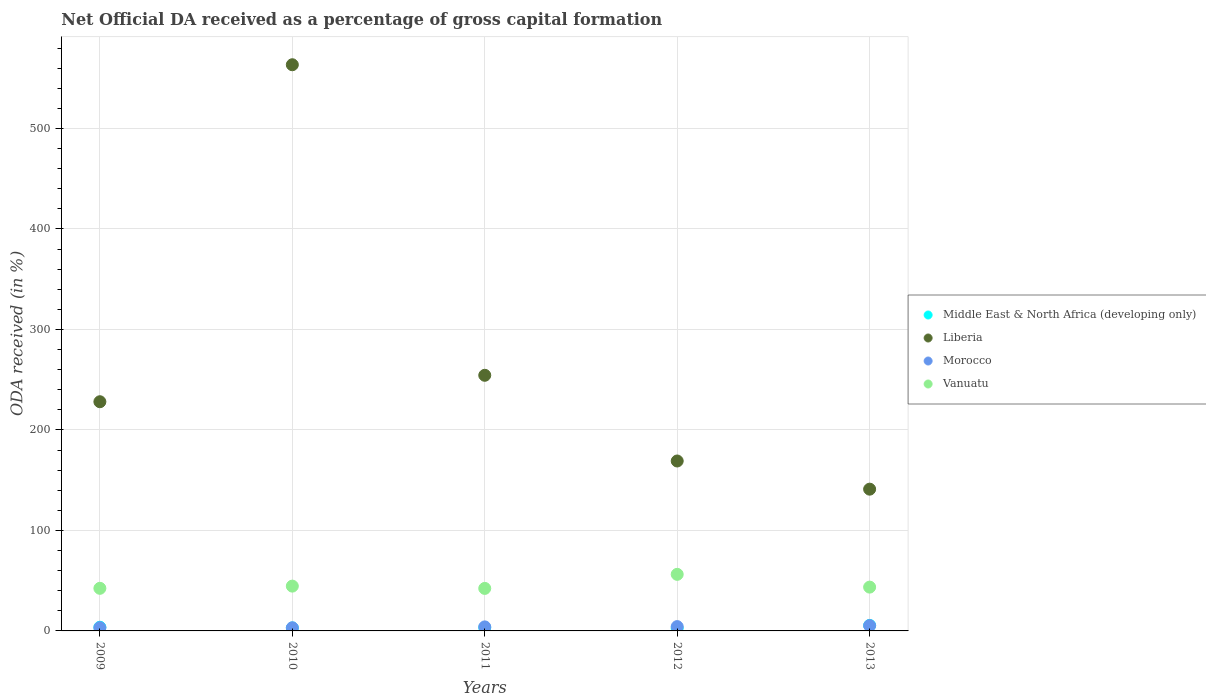What is the net ODA received in Liberia in 2011?
Offer a very short reply. 254.4. Across all years, what is the maximum net ODA received in Middle East & North Africa (developing only)?
Your response must be concise. 5.49. Across all years, what is the minimum net ODA received in Vanuatu?
Provide a short and direct response. 42.31. In which year was the net ODA received in Morocco maximum?
Offer a very short reply. 2013. In which year was the net ODA received in Morocco minimum?
Offer a very short reply. 2010. What is the total net ODA received in Vanuatu in the graph?
Your response must be concise. 229.19. What is the difference between the net ODA received in Morocco in 2010 and that in 2013?
Give a very brief answer. -2.15. What is the difference between the net ODA received in Liberia in 2011 and the net ODA received in Middle East & North Africa (developing only) in 2012?
Make the answer very short. 251.66. What is the average net ODA received in Liberia per year?
Offer a terse response. 271.22. In the year 2010, what is the difference between the net ODA received in Vanuatu and net ODA received in Morocco?
Your response must be concise. 41.47. What is the ratio of the net ODA received in Middle East & North Africa (developing only) in 2010 to that in 2013?
Make the answer very short. 0.54. Is the net ODA received in Middle East & North Africa (developing only) in 2010 less than that in 2012?
Provide a short and direct response. No. What is the difference between the highest and the second highest net ODA received in Middle East & North Africa (developing only)?
Your response must be concise. 1.82. What is the difference between the highest and the lowest net ODA received in Morocco?
Give a very brief answer. 2.15. Does the net ODA received in Liberia monotonically increase over the years?
Make the answer very short. No. How many years are there in the graph?
Make the answer very short. 5. Are the values on the major ticks of Y-axis written in scientific E-notation?
Provide a succinct answer. No. Does the graph contain grids?
Keep it short and to the point. Yes. Where does the legend appear in the graph?
Keep it short and to the point. Center right. What is the title of the graph?
Keep it short and to the point. Net Official DA received as a percentage of gross capital formation. Does "East Asia (all income levels)" appear as one of the legend labels in the graph?
Make the answer very short. No. What is the label or title of the X-axis?
Give a very brief answer. Years. What is the label or title of the Y-axis?
Keep it short and to the point. ODA received (in %). What is the ODA received (in %) in Middle East & North Africa (developing only) in 2009?
Keep it short and to the point. 3.67. What is the ODA received (in %) of Liberia in 2009?
Offer a very short reply. 228.08. What is the ODA received (in %) in Morocco in 2009?
Your answer should be compact. 3.22. What is the ODA received (in %) of Vanuatu in 2009?
Make the answer very short. 42.4. What is the ODA received (in %) of Middle East & North Africa (developing only) in 2010?
Your answer should be compact. 2.96. What is the ODA received (in %) of Liberia in 2010?
Your answer should be compact. 563.45. What is the ODA received (in %) of Morocco in 2010?
Your response must be concise. 3.12. What is the ODA received (in %) of Vanuatu in 2010?
Offer a very short reply. 44.59. What is the ODA received (in %) of Middle East & North Africa (developing only) in 2011?
Your answer should be very brief. 3.27. What is the ODA received (in %) in Liberia in 2011?
Keep it short and to the point. 254.4. What is the ODA received (in %) of Morocco in 2011?
Your answer should be very brief. 4.01. What is the ODA received (in %) of Vanuatu in 2011?
Provide a short and direct response. 42.31. What is the ODA received (in %) in Middle East & North Africa (developing only) in 2012?
Your response must be concise. 2.73. What is the ODA received (in %) in Liberia in 2012?
Make the answer very short. 169.11. What is the ODA received (in %) in Morocco in 2012?
Provide a short and direct response. 4.3. What is the ODA received (in %) of Vanuatu in 2012?
Ensure brevity in your answer.  56.3. What is the ODA received (in %) of Middle East & North Africa (developing only) in 2013?
Your response must be concise. 5.49. What is the ODA received (in %) of Liberia in 2013?
Give a very brief answer. 141.07. What is the ODA received (in %) in Morocco in 2013?
Offer a terse response. 5.28. What is the ODA received (in %) in Vanuatu in 2013?
Ensure brevity in your answer.  43.59. Across all years, what is the maximum ODA received (in %) in Middle East & North Africa (developing only)?
Provide a succinct answer. 5.49. Across all years, what is the maximum ODA received (in %) of Liberia?
Keep it short and to the point. 563.45. Across all years, what is the maximum ODA received (in %) of Morocco?
Offer a very short reply. 5.28. Across all years, what is the maximum ODA received (in %) in Vanuatu?
Offer a very short reply. 56.3. Across all years, what is the minimum ODA received (in %) in Middle East & North Africa (developing only)?
Make the answer very short. 2.73. Across all years, what is the minimum ODA received (in %) in Liberia?
Make the answer very short. 141.07. Across all years, what is the minimum ODA received (in %) in Morocco?
Provide a succinct answer. 3.12. Across all years, what is the minimum ODA received (in %) of Vanuatu?
Keep it short and to the point. 42.31. What is the total ODA received (in %) of Middle East & North Africa (developing only) in the graph?
Keep it short and to the point. 18.11. What is the total ODA received (in %) of Liberia in the graph?
Offer a terse response. 1356.11. What is the total ODA received (in %) in Morocco in the graph?
Your answer should be very brief. 19.94. What is the total ODA received (in %) in Vanuatu in the graph?
Give a very brief answer. 229.19. What is the difference between the ODA received (in %) in Middle East & North Africa (developing only) in 2009 and that in 2010?
Offer a very short reply. 0.71. What is the difference between the ODA received (in %) of Liberia in 2009 and that in 2010?
Your answer should be very brief. -335.37. What is the difference between the ODA received (in %) of Morocco in 2009 and that in 2010?
Ensure brevity in your answer.  0.09. What is the difference between the ODA received (in %) in Vanuatu in 2009 and that in 2010?
Your answer should be very brief. -2.19. What is the difference between the ODA received (in %) in Middle East & North Africa (developing only) in 2009 and that in 2011?
Provide a short and direct response. 0.4. What is the difference between the ODA received (in %) in Liberia in 2009 and that in 2011?
Your response must be concise. -26.31. What is the difference between the ODA received (in %) in Morocco in 2009 and that in 2011?
Make the answer very short. -0.8. What is the difference between the ODA received (in %) of Vanuatu in 2009 and that in 2011?
Your answer should be compact. 0.09. What is the difference between the ODA received (in %) of Middle East & North Africa (developing only) in 2009 and that in 2012?
Offer a terse response. 0.93. What is the difference between the ODA received (in %) in Liberia in 2009 and that in 2012?
Give a very brief answer. 58.97. What is the difference between the ODA received (in %) in Morocco in 2009 and that in 2012?
Make the answer very short. -1.09. What is the difference between the ODA received (in %) of Middle East & North Africa (developing only) in 2009 and that in 2013?
Provide a succinct answer. -1.82. What is the difference between the ODA received (in %) of Liberia in 2009 and that in 2013?
Ensure brevity in your answer.  87.01. What is the difference between the ODA received (in %) of Morocco in 2009 and that in 2013?
Provide a short and direct response. -2.06. What is the difference between the ODA received (in %) of Vanuatu in 2009 and that in 2013?
Provide a succinct answer. -1.19. What is the difference between the ODA received (in %) in Middle East & North Africa (developing only) in 2010 and that in 2011?
Your answer should be very brief. -0.31. What is the difference between the ODA received (in %) in Liberia in 2010 and that in 2011?
Give a very brief answer. 309.05. What is the difference between the ODA received (in %) in Morocco in 2010 and that in 2011?
Provide a short and direct response. -0.89. What is the difference between the ODA received (in %) in Vanuatu in 2010 and that in 2011?
Keep it short and to the point. 2.29. What is the difference between the ODA received (in %) in Middle East & North Africa (developing only) in 2010 and that in 2012?
Make the answer very short. 0.23. What is the difference between the ODA received (in %) in Liberia in 2010 and that in 2012?
Your response must be concise. 394.34. What is the difference between the ODA received (in %) of Morocco in 2010 and that in 2012?
Provide a succinct answer. -1.18. What is the difference between the ODA received (in %) in Vanuatu in 2010 and that in 2012?
Your answer should be very brief. -11.71. What is the difference between the ODA received (in %) of Middle East & North Africa (developing only) in 2010 and that in 2013?
Provide a short and direct response. -2.53. What is the difference between the ODA received (in %) in Liberia in 2010 and that in 2013?
Ensure brevity in your answer.  422.38. What is the difference between the ODA received (in %) in Morocco in 2010 and that in 2013?
Your answer should be compact. -2.15. What is the difference between the ODA received (in %) of Vanuatu in 2010 and that in 2013?
Provide a short and direct response. 1. What is the difference between the ODA received (in %) in Middle East & North Africa (developing only) in 2011 and that in 2012?
Provide a short and direct response. 0.53. What is the difference between the ODA received (in %) of Liberia in 2011 and that in 2012?
Ensure brevity in your answer.  85.29. What is the difference between the ODA received (in %) in Morocco in 2011 and that in 2012?
Your answer should be compact. -0.29. What is the difference between the ODA received (in %) of Vanuatu in 2011 and that in 2012?
Ensure brevity in your answer.  -13.99. What is the difference between the ODA received (in %) in Middle East & North Africa (developing only) in 2011 and that in 2013?
Provide a succinct answer. -2.22. What is the difference between the ODA received (in %) of Liberia in 2011 and that in 2013?
Your response must be concise. 113.32. What is the difference between the ODA received (in %) in Morocco in 2011 and that in 2013?
Ensure brevity in your answer.  -1.26. What is the difference between the ODA received (in %) of Vanuatu in 2011 and that in 2013?
Make the answer very short. -1.28. What is the difference between the ODA received (in %) of Middle East & North Africa (developing only) in 2012 and that in 2013?
Offer a very short reply. -2.76. What is the difference between the ODA received (in %) of Liberia in 2012 and that in 2013?
Provide a short and direct response. 28.04. What is the difference between the ODA received (in %) of Morocco in 2012 and that in 2013?
Your response must be concise. -0.98. What is the difference between the ODA received (in %) of Vanuatu in 2012 and that in 2013?
Provide a short and direct response. 12.71. What is the difference between the ODA received (in %) of Middle East & North Africa (developing only) in 2009 and the ODA received (in %) of Liberia in 2010?
Provide a short and direct response. -559.78. What is the difference between the ODA received (in %) of Middle East & North Africa (developing only) in 2009 and the ODA received (in %) of Morocco in 2010?
Your answer should be very brief. 0.54. What is the difference between the ODA received (in %) in Middle East & North Africa (developing only) in 2009 and the ODA received (in %) in Vanuatu in 2010?
Make the answer very short. -40.93. What is the difference between the ODA received (in %) of Liberia in 2009 and the ODA received (in %) of Morocco in 2010?
Ensure brevity in your answer.  224.96. What is the difference between the ODA received (in %) of Liberia in 2009 and the ODA received (in %) of Vanuatu in 2010?
Offer a terse response. 183.49. What is the difference between the ODA received (in %) of Morocco in 2009 and the ODA received (in %) of Vanuatu in 2010?
Ensure brevity in your answer.  -41.37. What is the difference between the ODA received (in %) in Middle East & North Africa (developing only) in 2009 and the ODA received (in %) in Liberia in 2011?
Offer a very short reply. -250.73. What is the difference between the ODA received (in %) in Middle East & North Africa (developing only) in 2009 and the ODA received (in %) in Morocco in 2011?
Give a very brief answer. -0.35. What is the difference between the ODA received (in %) in Middle East & North Africa (developing only) in 2009 and the ODA received (in %) in Vanuatu in 2011?
Keep it short and to the point. -38.64. What is the difference between the ODA received (in %) of Liberia in 2009 and the ODA received (in %) of Morocco in 2011?
Give a very brief answer. 224.07. What is the difference between the ODA received (in %) in Liberia in 2009 and the ODA received (in %) in Vanuatu in 2011?
Offer a very short reply. 185.78. What is the difference between the ODA received (in %) in Morocco in 2009 and the ODA received (in %) in Vanuatu in 2011?
Make the answer very short. -39.09. What is the difference between the ODA received (in %) in Middle East & North Africa (developing only) in 2009 and the ODA received (in %) in Liberia in 2012?
Give a very brief answer. -165.44. What is the difference between the ODA received (in %) in Middle East & North Africa (developing only) in 2009 and the ODA received (in %) in Morocco in 2012?
Your response must be concise. -0.64. What is the difference between the ODA received (in %) of Middle East & North Africa (developing only) in 2009 and the ODA received (in %) of Vanuatu in 2012?
Offer a very short reply. -52.63. What is the difference between the ODA received (in %) in Liberia in 2009 and the ODA received (in %) in Morocco in 2012?
Provide a succinct answer. 223.78. What is the difference between the ODA received (in %) of Liberia in 2009 and the ODA received (in %) of Vanuatu in 2012?
Your response must be concise. 171.78. What is the difference between the ODA received (in %) of Morocco in 2009 and the ODA received (in %) of Vanuatu in 2012?
Provide a succinct answer. -53.08. What is the difference between the ODA received (in %) in Middle East & North Africa (developing only) in 2009 and the ODA received (in %) in Liberia in 2013?
Make the answer very short. -137.41. What is the difference between the ODA received (in %) of Middle East & North Africa (developing only) in 2009 and the ODA received (in %) of Morocco in 2013?
Your response must be concise. -1.61. What is the difference between the ODA received (in %) of Middle East & North Africa (developing only) in 2009 and the ODA received (in %) of Vanuatu in 2013?
Provide a succinct answer. -39.93. What is the difference between the ODA received (in %) in Liberia in 2009 and the ODA received (in %) in Morocco in 2013?
Make the answer very short. 222.81. What is the difference between the ODA received (in %) in Liberia in 2009 and the ODA received (in %) in Vanuatu in 2013?
Provide a short and direct response. 184.49. What is the difference between the ODA received (in %) of Morocco in 2009 and the ODA received (in %) of Vanuatu in 2013?
Ensure brevity in your answer.  -40.37. What is the difference between the ODA received (in %) in Middle East & North Africa (developing only) in 2010 and the ODA received (in %) in Liberia in 2011?
Make the answer very short. -251.44. What is the difference between the ODA received (in %) in Middle East & North Africa (developing only) in 2010 and the ODA received (in %) in Morocco in 2011?
Ensure brevity in your answer.  -1.06. What is the difference between the ODA received (in %) in Middle East & North Africa (developing only) in 2010 and the ODA received (in %) in Vanuatu in 2011?
Keep it short and to the point. -39.35. What is the difference between the ODA received (in %) of Liberia in 2010 and the ODA received (in %) of Morocco in 2011?
Your answer should be compact. 559.44. What is the difference between the ODA received (in %) in Liberia in 2010 and the ODA received (in %) in Vanuatu in 2011?
Offer a very short reply. 521.14. What is the difference between the ODA received (in %) in Morocco in 2010 and the ODA received (in %) in Vanuatu in 2011?
Give a very brief answer. -39.18. What is the difference between the ODA received (in %) of Middle East & North Africa (developing only) in 2010 and the ODA received (in %) of Liberia in 2012?
Ensure brevity in your answer.  -166.15. What is the difference between the ODA received (in %) in Middle East & North Africa (developing only) in 2010 and the ODA received (in %) in Morocco in 2012?
Offer a very short reply. -1.35. What is the difference between the ODA received (in %) of Middle East & North Africa (developing only) in 2010 and the ODA received (in %) of Vanuatu in 2012?
Offer a terse response. -53.34. What is the difference between the ODA received (in %) of Liberia in 2010 and the ODA received (in %) of Morocco in 2012?
Your answer should be compact. 559.15. What is the difference between the ODA received (in %) of Liberia in 2010 and the ODA received (in %) of Vanuatu in 2012?
Offer a terse response. 507.15. What is the difference between the ODA received (in %) of Morocco in 2010 and the ODA received (in %) of Vanuatu in 2012?
Your answer should be very brief. -53.17. What is the difference between the ODA received (in %) in Middle East & North Africa (developing only) in 2010 and the ODA received (in %) in Liberia in 2013?
Offer a very short reply. -138.12. What is the difference between the ODA received (in %) of Middle East & North Africa (developing only) in 2010 and the ODA received (in %) of Morocco in 2013?
Give a very brief answer. -2.32. What is the difference between the ODA received (in %) of Middle East & North Africa (developing only) in 2010 and the ODA received (in %) of Vanuatu in 2013?
Your response must be concise. -40.63. What is the difference between the ODA received (in %) in Liberia in 2010 and the ODA received (in %) in Morocco in 2013?
Ensure brevity in your answer.  558.17. What is the difference between the ODA received (in %) of Liberia in 2010 and the ODA received (in %) of Vanuatu in 2013?
Make the answer very short. 519.86. What is the difference between the ODA received (in %) in Morocco in 2010 and the ODA received (in %) in Vanuatu in 2013?
Your response must be concise. -40.47. What is the difference between the ODA received (in %) in Middle East & North Africa (developing only) in 2011 and the ODA received (in %) in Liberia in 2012?
Make the answer very short. -165.84. What is the difference between the ODA received (in %) of Middle East & North Africa (developing only) in 2011 and the ODA received (in %) of Morocco in 2012?
Offer a very short reply. -1.04. What is the difference between the ODA received (in %) of Middle East & North Africa (developing only) in 2011 and the ODA received (in %) of Vanuatu in 2012?
Offer a terse response. -53.03. What is the difference between the ODA received (in %) in Liberia in 2011 and the ODA received (in %) in Morocco in 2012?
Ensure brevity in your answer.  250.09. What is the difference between the ODA received (in %) of Liberia in 2011 and the ODA received (in %) of Vanuatu in 2012?
Make the answer very short. 198.1. What is the difference between the ODA received (in %) of Morocco in 2011 and the ODA received (in %) of Vanuatu in 2012?
Keep it short and to the point. -52.29. What is the difference between the ODA received (in %) of Middle East & North Africa (developing only) in 2011 and the ODA received (in %) of Liberia in 2013?
Ensure brevity in your answer.  -137.81. What is the difference between the ODA received (in %) of Middle East & North Africa (developing only) in 2011 and the ODA received (in %) of Morocco in 2013?
Give a very brief answer. -2.01. What is the difference between the ODA received (in %) of Middle East & North Africa (developing only) in 2011 and the ODA received (in %) of Vanuatu in 2013?
Your answer should be compact. -40.33. What is the difference between the ODA received (in %) of Liberia in 2011 and the ODA received (in %) of Morocco in 2013?
Provide a succinct answer. 249.12. What is the difference between the ODA received (in %) of Liberia in 2011 and the ODA received (in %) of Vanuatu in 2013?
Ensure brevity in your answer.  210.8. What is the difference between the ODA received (in %) of Morocco in 2011 and the ODA received (in %) of Vanuatu in 2013?
Your answer should be very brief. -39.58. What is the difference between the ODA received (in %) of Middle East & North Africa (developing only) in 2012 and the ODA received (in %) of Liberia in 2013?
Give a very brief answer. -138.34. What is the difference between the ODA received (in %) of Middle East & North Africa (developing only) in 2012 and the ODA received (in %) of Morocco in 2013?
Offer a very short reply. -2.55. What is the difference between the ODA received (in %) in Middle East & North Africa (developing only) in 2012 and the ODA received (in %) in Vanuatu in 2013?
Keep it short and to the point. -40.86. What is the difference between the ODA received (in %) in Liberia in 2012 and the ODA received (in %) in Morocco in 2013?
Give a very brief answer. 163.83. What is the difference between the ODA received (in %) of Liberia in 2012 and the ODA received (in %) of Vanuatu in 2013?
Provide a short and direct response. 125.52. What is the difference between the ODA received (in %) in Morocco in 2012 and the ODA received (in %) in Vanuatu in 2013?
Keep it short and to the point. -39.29. What is the average ODA received (in %) in Middle East & North Africa (developing only) per year?
Your answer should be very brief. 3.62. What is the average ODA received (in %) in Liberia per year?
Provide a succinct answer. 271.22. What is the average ODA received (in %) in Morocco per year?
Ensure brevity in your answer.  3.99. What is the average ODA received (in %) of Vanuatu per year?
Ensure brevity in your answer.  45.84. In the year 2009, what is the difference between the ODA received (in %) of Middle East & North Africa (developing only) and ODA received (in %) of Liberia?
Make the answer very short. -224.42. In the year 2009, what is the difference between the ODA received (in %) in Middle East & North Africa (developing only) and ODA received (in %) in Morocco?
Provide a succinct answer. 0.45. In the year 2009, what is the difference between the ODA received (in %) of Middle East & North Africa (developing only) and ODA received (in %) of Vanuatu?
Ensure brevity in your answer.  -38.73. In the year 2009, what is the difference between the ODA received (in %) of Liberia and ODA received (in %) of Morocco?
Give a very brief answer. 224.87. In the year 2009, what is the difference between the ODA received (in %) in Liberia and ODA received (in %) in Vanuatu?
Ensure brevity in your answer.  185.68. In the year 2009, what is the difference between the ODA received (in %) in Morocco and ODA received (in %) in Vanuatu?
Your answer should be compact. -39.18. In the year 2010, what is the difference between the ODA received (in %) in Middle East & North Africa (developing only) and ODA received (in %) in Liberia?
Make the answer very short. -560.49. In the year 2010, what is the difference between the ODA received (in %) in Middle East & North Africa (developing only) and ODA received (in %) in Morocco?
Offer a terse response. -0.17. In the year 2010, what is the difference between the ODA received (in %) of Middle East & North Africa (developing only) and ODA received (in %) of Vanuatu?
Your response must be concise. -41.63. In the year 2010, what is the difference between the ODA received (in %) of Liberia and ODA received (in %) of Morocco?
Provide a succinct answer. 560.32. In the year 2010, what is the difference between the ODA received (in %) of Liberia and ODA received (in %) of Vanuatu?
Keep it short and to the point. 518.86. In the year 2010, what is the difference between the ODA received (in %) in Morocco and ODA received (in %) in Vanuatu?
Keep it short and to the point. -41.47. In the year 2011, what is the difference between the ODA received (in %) in Middle East & North Africa (developing only) and ODA received (in %) in Liberia?
Your response must be concise. -251.13. In the year 2011, what is the difference between the ODA received (in %) of Middle East & North Africa (developing only) and ODA received (in %) of Morocco?
Ensure brevity in your answer.  -0.75. In the year 2011, what is the difference between the ODA received (in %) in Middle East & North Africa (developing only) and ODA received (in %) in Vanuatu?
Give a very brief answer. -39.04. In the year 2011, what is the difference between the ODA received (in %) in Liberia and ODA received (in %) in Morocco?
Provide a succinct answer. 250.38. In the year 2011, what is the difference between the ODA received (in %) of Liberia and ODA received (in %) of Vanuatu?
Your response must be concise. 212.09. In the year 2011, what is the difference between the ODA received (in %) in Morocco and ODA received (in %) in Vanuatu?
Provide a succinct answer. -38.29. In the year 2012, what is the difference between the ODA received (in %) of Middle East & North Africa (developing only) and ODA received (in %) of Liberia?
Provide a succinct answer. -166.38. In the year 2012, what is the difference between the ODA received (in %) in Middle East & North Africa (developing only) and ODA received (in %) in Morocco?
Provide a succinct answer. -1.57. In the year 2012, what is the difference between the ODA received (in %) of Middle East & North Africa (developing only) and ODA received (in %) of Vanuatu?
Provide a short and direct response. -53.57. In the year 2012, what is the difference between the ODA received (in %) of Liberia and ODA received (in %) of Morocco?
Provide a short and direct response. 164.81. In the year 2012, what is the difference between the ODA received (in %) of Liberia and ODA received (in %) of Vanuatu?
Provide a succinct answer. 112.81. In the year 2012, what is the difference between the ODA received (in %) in Morocco and ODA received (in %) in Vanuatu?
Give a very brief answer. -52. In the year 2013, what is the difference between the ODA received (in %) of Middle East & North Africa (developing only) and ODA received (in %) of Liberia?
Make the answer very short. -135.59. In the year 2013, what is the difference between the ODA received (in %) in Middle East & North Africa (developing only) and ODA received (in %) in Morocco?
Keep it short and to the point. 0.21. In the year 2013, what is the difference between the ODA received (in %) of Middle East & North Africa (developing only) and ODA received (in %) of Vanuatu?
Your answer should be compact. -38.1. In the year 2013, what is the difference between the ODA received (in %) in Liberia and ODA received (in %) in Morocco?
Provide a succinct answer. 135.79. In the year 2013, what is the difference between the ODA received (in %) in Liberia and ODA received (in %) in Vanuatu?
Make the answer very short. 97.48. In the year 2013, what is the difference between the ODA received (in %) of Morocco and ODA received (in %) of Vanuatu?
Your response must be concise. -38.31. What is the ratio of the ODA received (in %) of Middle East & North Africa (developing only) in 2009 to that in 2010?
Your response must be concise. 1.24. What is the ratio of the ODA received (in %) in Liberia in 2009 to that in 2010?
Keep it short and to the point. 0.4. What is the ratio of the ODA received (in %) in Morocco in 2009 to that in 2010?
Keep it short and to the point. 1.03. What is the ratio of the ODA received (in %) of Vanuatu in 2009 to that in 2010?
Your answer should be very brief. 0.95. What is the ratio of the ODA received (in %) of Middle East & North Africa (developing only) in 2009 to that in 2011?
Offer a very short reply. 1.12. What is the ratio of the ODA received (in %) in Liberia in 2009 to that in 2011?
Your answer should be compact. 0.9. What is the ratio of the ODA received (in %) in Morocco in 2009 to that in 2011?
Your answer should be compact. 0.8. What is the ratio of the ODA received (in %) of Middle East & North Africa (developing only) in 2009 to that in 2012?
Keep it short and to the point. 1.34. What is the ratio of the ODA received (in %) of Liberia in 2009 to that in 2012?
Your response must be concise. 1.35. What is the ratio of the ODA received (in %) of Morocco in 2009 to that in 2012?
Provide a short and direct response. 0.75. What is the ratio of the ODA received (in %) in Vanuatu in 2009 to that in 2012?
Ensure brevity in your answer.  0.75. What is the ratio of the ODA received (in %) in Middle East & North Africa (developing only) in 2009 to that in 2013?
Your answer should be very brief. 0.67. What is the ratio of the ODA received (in %) in Liberia in 2009 to that in 2013?
Provide a short and direct response. 1.62. What is the ratio of the ODA received (in %) in Morocco in 2009 to that in 2013?
Keep it short and to the point. 0.61. What is the ratio of the ODA received (in %) of Vanuatu in 2009 to that in 2013?
Ensure brevity in your answer.  0.97. What is the ratio of the ODA received (in %) in Middle East & North Africa (developing only) in 2010 to that in 2011?
Offer a very short reply. 0.91. What is the ratio of the ODA received (in %) in Liberia in 2010 to that in 2011?
Provide a short and direct response. 2.21. What is the ratio of the ODA received (in %) of Morocco in 2010 to that in 2011?
Offer a very short reply. 0.78. What is the ratio of the ODA received (in %) in Vanuatu in 2010 to that in 2011?
Provide a succinct answer. 1.05. What is the ratio of the ODA received (in %) of Middle East & North Africa (developing only) in 2010 to that in 2012?
Make the answer very short. 1.08. What is the ratio of the ODA received (in %) in Liberia in 2010 to that in 2012?
Keep it short and to the point. 3.33. What is the ratio of the ODA received (in %) of Morocco in 2010 to that in 2012?
Provide a short and direct response. 0.73. What is the ratio of the ODA received (in %) of Vanuatu in 2010 to that in 2012?
Your answer should be compact. 0.79. What is the ratio of the ODA received (in %) in Middle East & North Africa (developing only) in 2010 to that in 2013?
Offer a terse response. 0.54. What is the ratio of the ODA received (in %) in Liberia in 2010 to that in 2013?
Give a very brief answer. 3.99. What is the ratio of the ODA received (in %) of Morocco in 2010 to that in 2013?
Offer a very short reply. 0.59. What is the ratio of the ODA received (in %) of Middle East & North Africa (developing only) in 2011 to that in 2012?
Keep it short and to the point. 1.2. What is the ratio of the ODA received (in %) of Liberia in 2011 to that in 2012?
Ensure brevity in your answer.  1.5. What is the ratio of the ODA received (in %) in Morocco in 2011 to that in 2012?
Your answer should be very brief. 0.93. What is the ratio of the ODA received (in %) of Vanuatu in 2011 to that in 2012?
Your answer should be very brief. 0.75. What is the ratio of the ODA received (in %) of Middle East & North Africa (developing only) in 2011 to that in 2013?
Provide a succinct answer. 0.59. What is the ratio of the ODA received (in %) in Liberia in 2011 to that in 2013?
Make the answer very short. 1.8. What is the ratio of the ODA received (in %) of Morocco in 2011 to that in 2013?
Your response must be concise. 0.76. What is the ratio of the ODA received (in %) of Vanuatu in 2011 to that in 2013?
Provide a short and direct response. 0.97. What is the ratio of the ODA received (in %) in Middle East & North Africa (developing only) in 2012 to that in 2013?
Your response must be concise. 0.5. What is the ratio of the ODA received (in %) in Liberia in 2012 to that in 2013?
Offer a very short reply. 1.2. What is the ratio of the ODA received (in %) in Morocco in 2012 to that in 2013?
Ensure brevity in your answer.  0.81. What is the ratio of the ODA received (in %) of Vanuatu in 2012 to that in 2013?
Your response must be concise. 1.29. What is the difference between the highest and the second highest ODA received (in %) of Middle East & North Africa (developing only)?
Your answer should be very brief. 1.82. What is the difference between the highest and the second highest ODA received (in %) of Liberia?
Provide a succinct answer. 309.05. What is the difference between the highest and the second highest ODA received (in %) of Morocco?
Ensure brevity in your answer.  0.98. What is the difference between the highest and the second highest ODA received (in %) in Vanuatu?
Ensure brevity in your answer.  11.71. What is the difference between the highest and the lowest ODA received (in %) in Middle East & North Africa (developing only)?
Keep it short and to the point. 2.76. What is the difference between the highest and the lowest ODA received (in %) in Liberia?
Offer a very short reply. 422.38. What is the difference between the highest and the lowest ODA received (in %) of Morocco?
Make the answer very short. 2.15. What is the difference between the highest and the lowest ODA received (in %) of Vanuatu?
Your response must be concise. 13.99. 